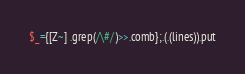<code> <loc_0><loc_0><loc_500><loc_500><_Perl_>$_={[Z~] .grep(/\#/)>>.comb};.(.(lines)).put</code> 